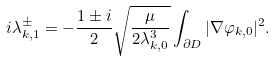Convert formula to latex. <formula><loc_0><loc_0><loc_500><loc_500>i \lambda _ { k , 1 } ^ { \pm } = - \frac { 1 \pm i } { 2 } \sqrt { \frac { \mu } { 2 \lambda _ { k , 0 } ^ { 3 } } } \int _ { \partial D } | \nabla \varphi _ { k , 0 } | ^ { 2 } .</formula> 